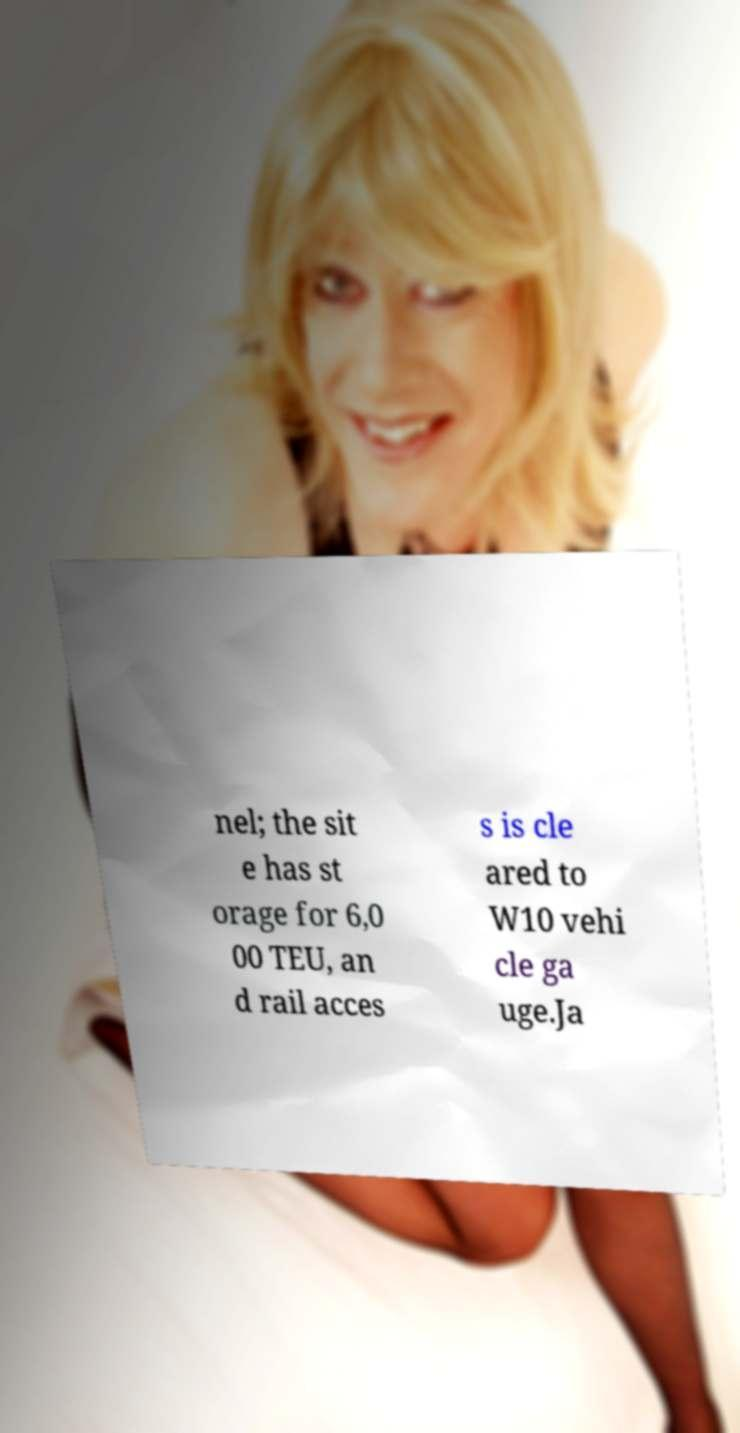For documentation purposes, I need the text within this image transcribed. Could you provide that? nel; the sit e has st orage for 6,0 00 TEU, an d rail acces s is cle ared to W10 vehi cle ga uge.Ja 